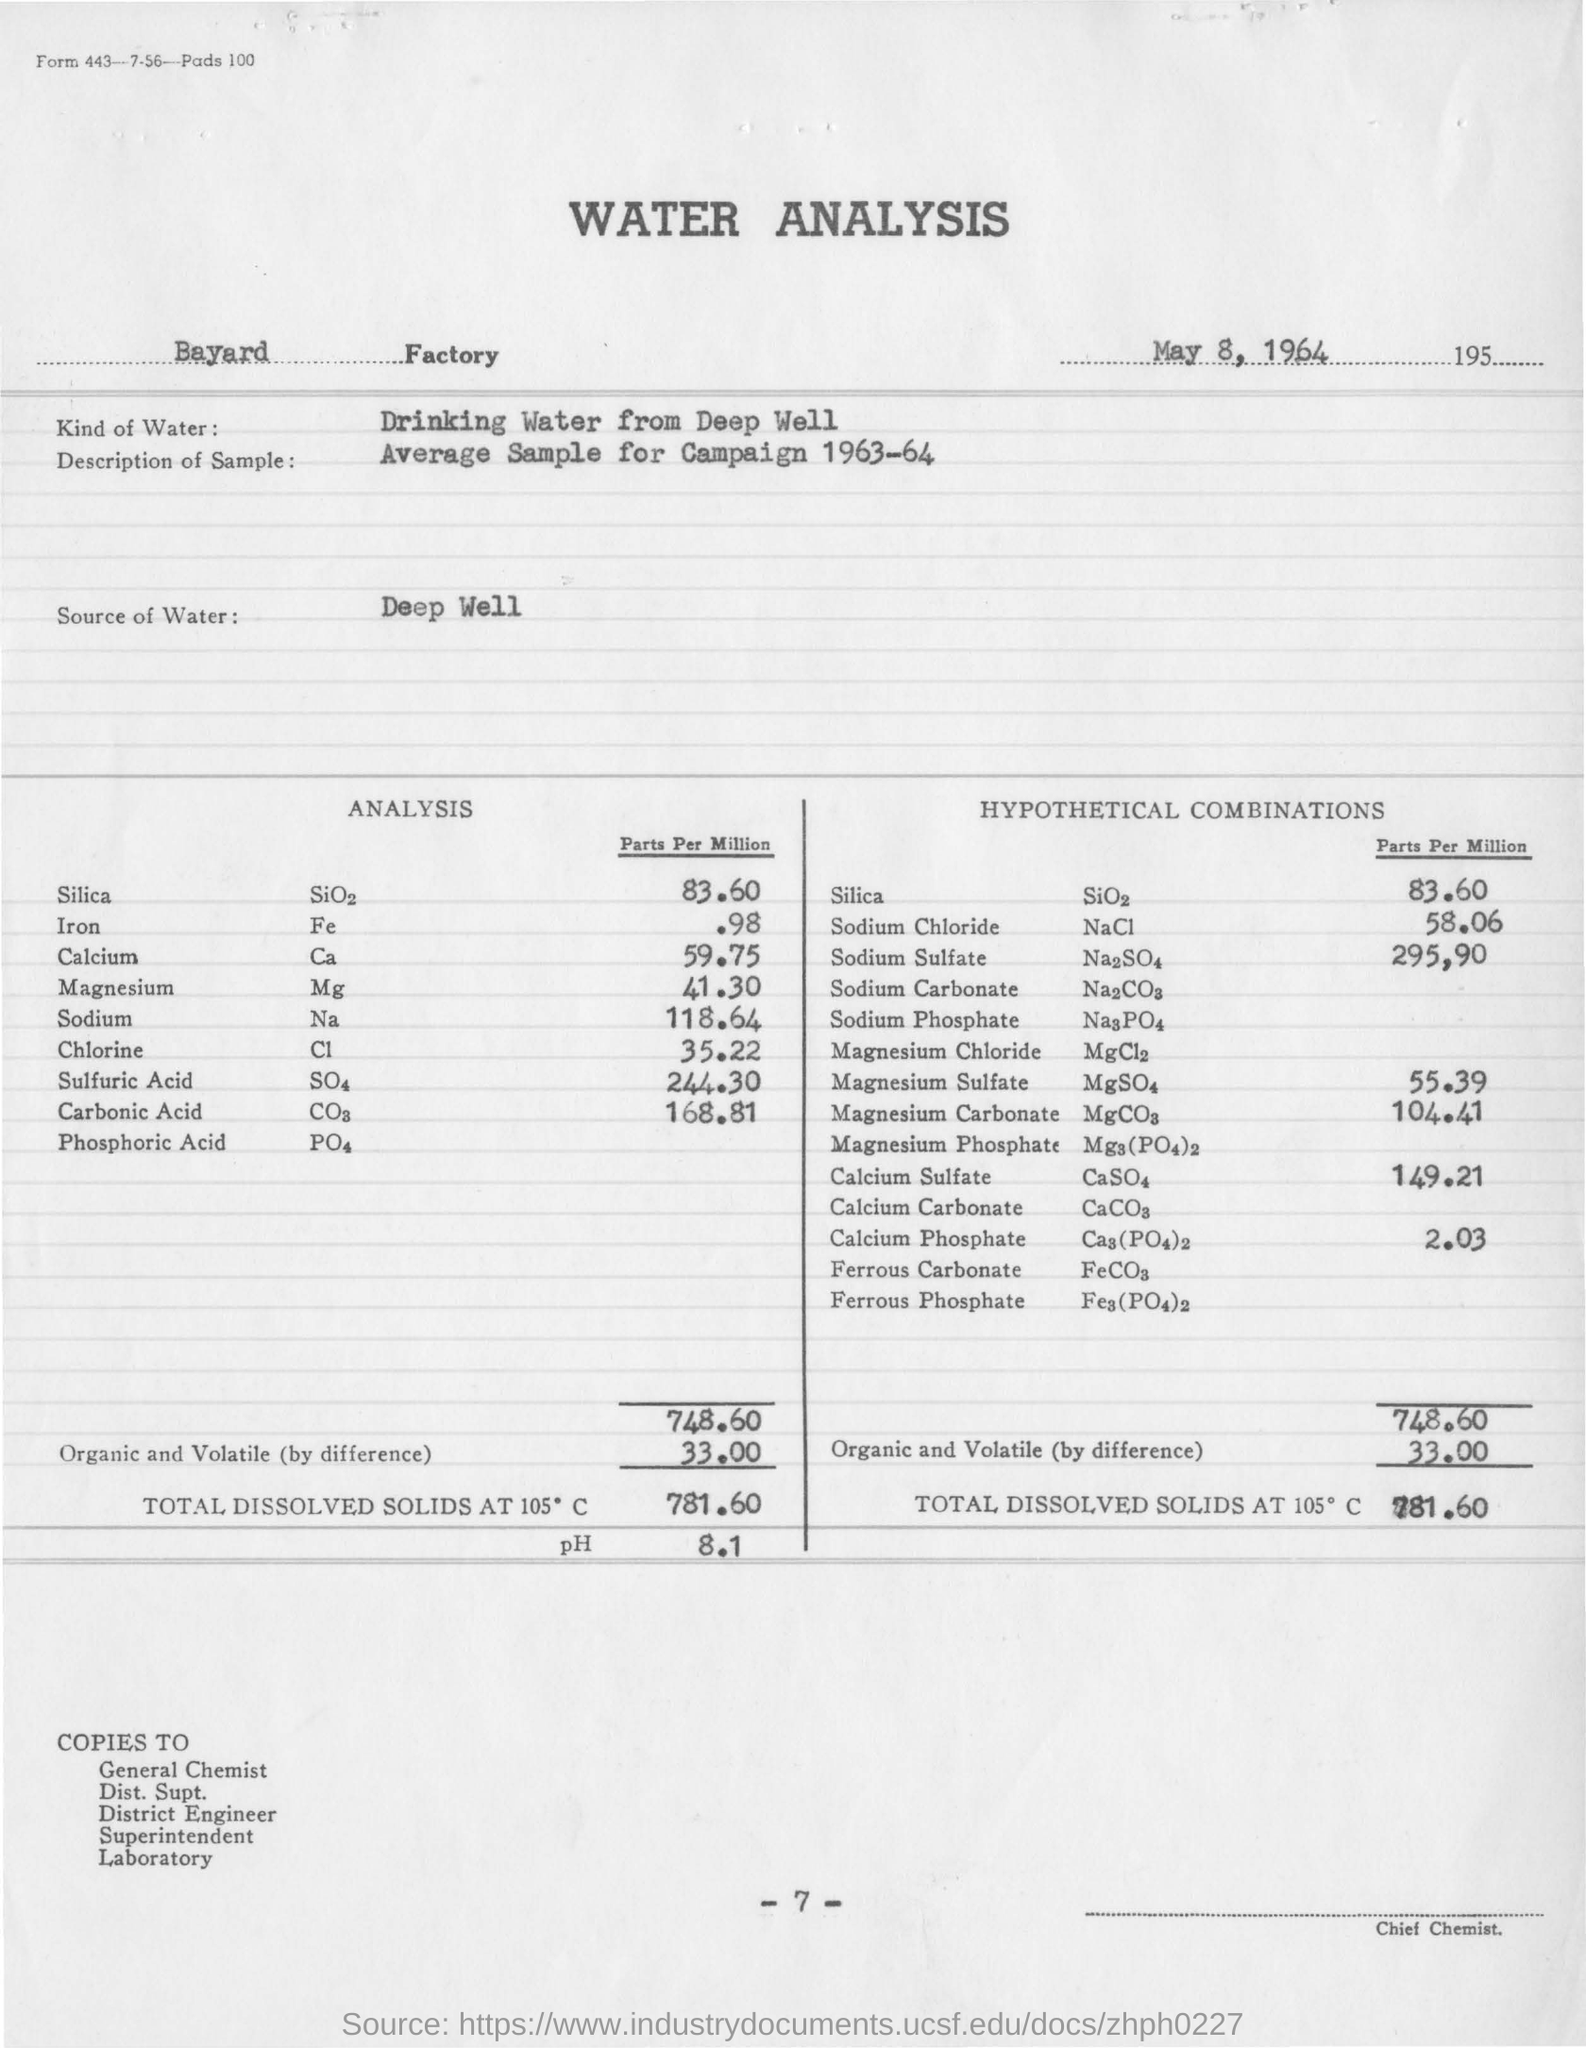List a handful of essential elements in this visual. The type of water used in water analysis is deep well drinking water. The analysis revealed that there is 0.98 parts per million of iron present in the sample. The water analysis was conducted on May 8, 1964. The water analysis is conducted at the Bayard Factory. The pH value obtained in the water analysis was 8.1. 